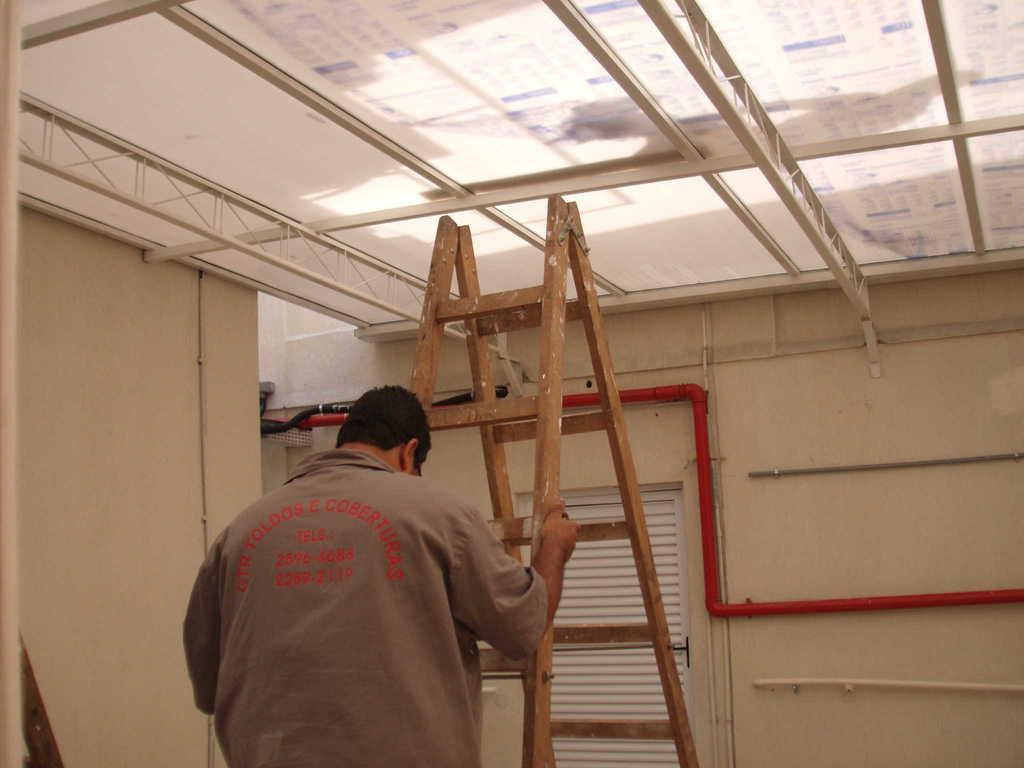Can you describe this image briefly? In the center of the picture there is a person climbing a ladder. On the left it is well. On the right there is pipe on the wall. At the top of there are iron frames and ceiling. In the center of the background there are pipes and wall and there is a window blind also. 